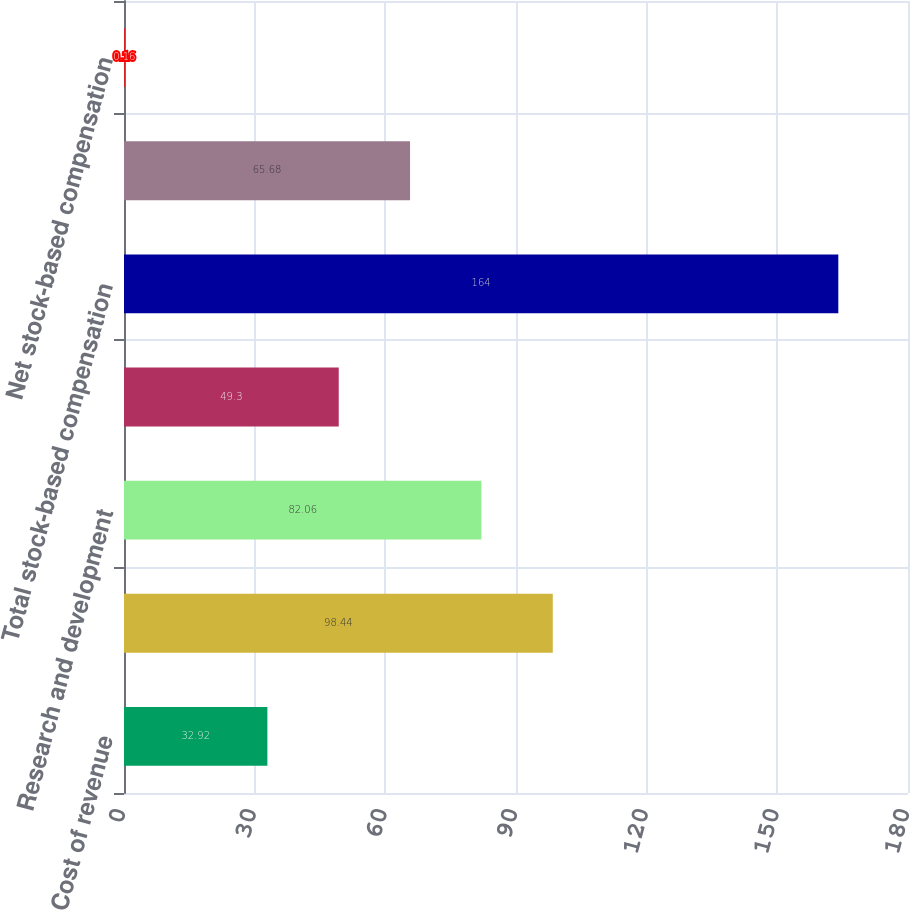Convert chart. <chart><loc_0><loc_0><loc_500><loc_500><bar_chart><fcel>Cost of revenue<fcel>Sales and marketing<fcel>Research and development<fcel>General and administrative<fcel>Total stock-based compensation<fcel>Tax benefit associated with<fcel>Net stock-based compensation<nl><fcel>32.92<fcel>98.44<fcel>82.06<fcel>49.3<fcel>164<fcel>65.68<fcel>0.16<nl></chart> 